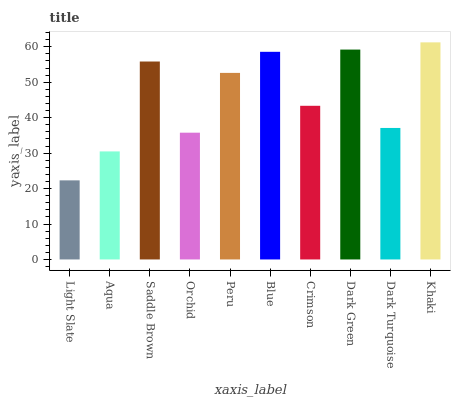Is Light Slate the minimum?
Answer yes or no. Yes. Is Khaki the maximum?
Answer yes or no. Yes. Is Aqua the minimum?
Answer yes or no. No. Is Aqua the maximum?
Answer yes or no. No. Is Aqua greater than Light Slate?
Answer yes or no. Yes. Is Light Slate less than Aqua?
Answer yes or no. Yes. Is Light Slate greater than Aqua?
Answer yes or no. No. Is Aqua less than Light Slate?
Answer yes or no. No. Is Peru the high median?
Answer yes or no. Yes. Is Crimson the low median?
Answer yes or no. Yes. Is Aqua the high median?
Answer yes or no. No. Is Dark Green the low median?
Answer yes or no. No. 